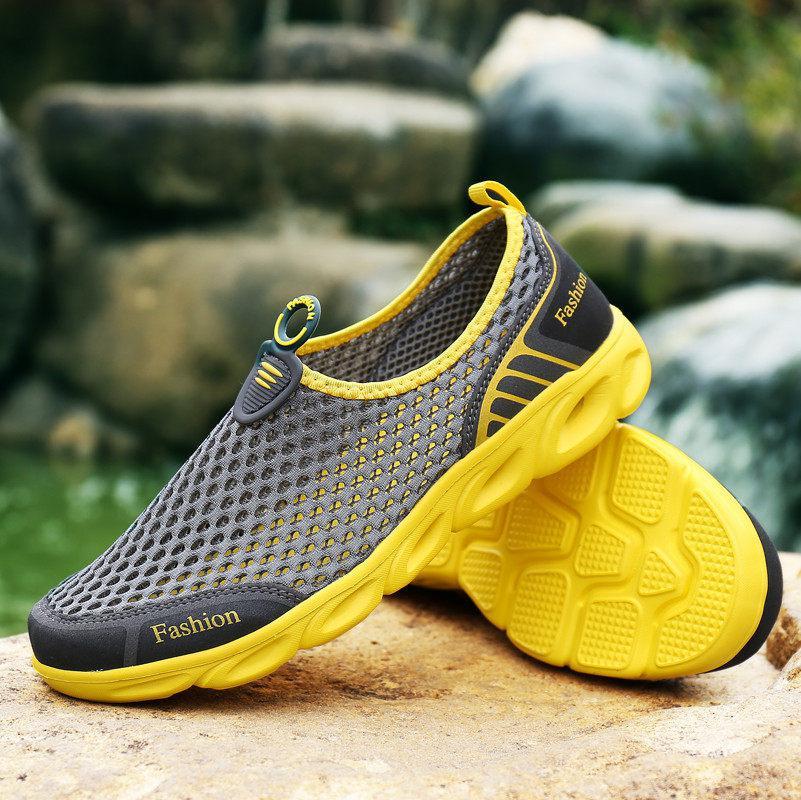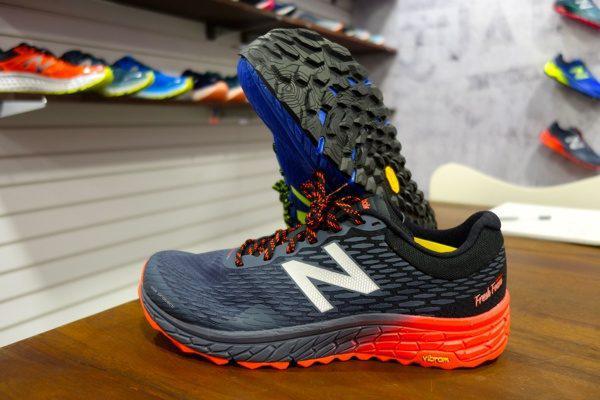The first image is the image on the left, the second image is the image on the right. Assess this claim about the two images: "An image shows a pair of black sneakers posed on a shoe box.". Correct or not? Answer yes or no. No. The first image is the image on the left, the second image is the image on the right. For the images shown, is this caption "There is a black pair of sneakers sitting on a shoe box in the image on the right." true? Answer yes or no. No. 